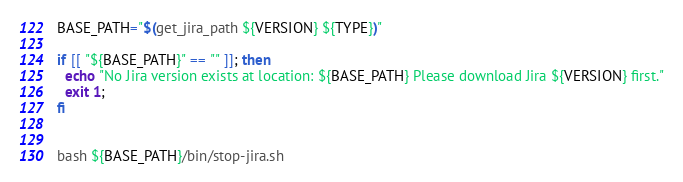<code> <loc_0><loc_0><loc_500><loc_500><_Bash_>BASE_PATH="$(get_jira_path ${VERSION} ${TYPE})"

if [[ "${BASE_PATH}" == "" ]]; then
  echo "No Jira version exists at location: ${BASE_PATH} Please download Jira ${VERSION} first."
  exit 1;
fi


bash ${BASE_PATH}/bin/stop-jira.sh
</code> 